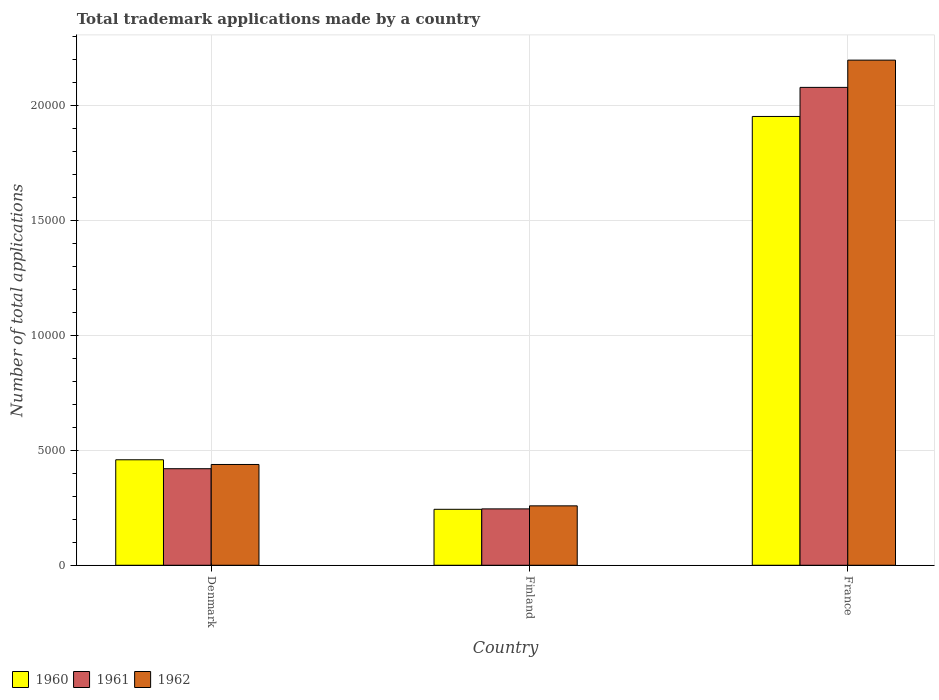How many groups of bars are there?
Offer a very short reply. 3. Are the number of bars per tick equal to the number of legend labels?
Offer a terse response. Yes. Are the number of bars on each tick of the X-axis equal?
Offer a terse response. Yes. How many bars are there on the 3rd tick from the left?
Your response must be concise. 3. What is the number of applications made by in 1961 in France?
Your answer should be very brief. 2.08e+04. Across all countries, what is the maximum number of applications made by in 1960?
Your answer should be very brief. 1.95e+04. Across all countries, what is the minimum number of applications made by in 1962?
Offer a very short reply. 2582. What is the total number of applications made by in 1960 in the graph?
Ensure brevity in your answer.  2.65e+04. What is the difference between the number of applications made by in 1961 in Denmark and that in France?
Provide a short and direct response. -1.66e+04. What is the difference between the number of applications made by in 1960 in Finland and the number of applications made by in 1962 in Denmark?
Ensure brevity in your answer.  -1948. What is the average number of applications made by in 1961 per country?
Give a very brief answer. 9138. What is the difference between the number of applications made by of/in 1960 and number of applications made by of/in 1961 in France?
Make the answer very short. -1264. In how many countries, is the number of applications made by in 1960 greater than 17000?
Provide a succinct answer. 1. What is the ratio of the number of applications made by in 1962 in Finland to that in France?
Your answer should be compact. 0.12. Is the number of applications made by in 1961 in Denmark less than that in France?
Keep it short and to the point. Yes. Is the difference between the number of applications made by in 1960 in Finland and France greater than the difference between the number of applications made by in 1961 in Finland and France?
Your answer should be compact. Yes. What is the difference between the highest and the second highest number of applications made by in 1961?
Your answer should be compact. 1.83e+04. What is the difference between the highest and the lowest number of applications made by in 1961?
Your response must be concise. 1.83e+04. In how many countries, is the number of applications made by in 1961 greater than the average number of applications made by in 1961 taken over all countries?
Keep it short and to the point. 1. Is the sum of the number of applications made by in 1962 in Denmark and Finland greater than the maximum number of applications made by in 1960 across all countries?
Your answer should be very brief. No. What does the 3rd bar from the left in Finland represents?
Keep it short and to the point. 1962. What does the 3rd bar from the right in Finland represents?
Offer a very short reply. 1960. Is it the case that in every country, the sum of the number of applications made by in 1962 and number of applications made by in 1961 is greater than the number of applications made by in 1960?
Offer a very short reply. Yes. Are all the bars in the graph horizontal?
Offer a very short reply. No. Does the graph contain grids?
Ensure brevity in your answer.  Yes. Where does the legend appear in the graph?
Keep it short and to the point. Bottom left. What is the title of the graph?
Your answer should be compact. Total trademark applications made by a country. What is the label or title of the X-axis?
Provide a succinct answer. Country. What is the label or title of the Y-axis?
Keep it short and to the point. Number of total applications. What is the Number of total applications in 1960 in Denmark?
Offer a terse response. 4584. What is the Number of total applications in 1961 in Denmark?
Your response must be concise. 4196. What is the Number of total applications of 1962 in Denmark?
Your response must be concise. 4380. What is the Number of total applications in 1960 in Finland?
Your answer should be very brief. 2432. What is the Number of total applications in 1961 in Finland?
Your response must be concise. 2450. What is the Number of total applications of 1962 in Finland?
Offer a terse response. 2582. What is the Number of total applications in 1960 in France?
Keep it short and to the point. 1.95e+04. What is the Number of total applications in 1961 in France?
Your response must be concise. 2.08e+04. What is the Number of total applications of 1962 in France?
Your answer should be very brief. 2.20e+04. Across all countries, what is the maximum Number of total applications in 1960?
Your answer should be very brief. 1.95e+04. Across all countries, what is the maximum Number of total applications of 1961?
Ensure brevity in your answer.  2.08e+04. Across all countries, what is the maximum Number of total applications of 1962?
Provide a short and direct response. 2.20e+04. Across all countries, what is the minimum Number of total applications in 1960?
Keep it short and to the point. 2432. Across all countries, what is the minimum Number of total applications in 1961?
Your answer should be very brief. 2450. Across all countries, what is the minimum Number of total applications in 1962?
Provide a succinct answer. 2582. What is the total Number of total applications of 1960 in the graph?
Offer a very short reply. 2.65e+04. What is the total Number of total applications of 1961 in the graph?
Offer a very short reply. 2.74e+04. What is the total Number of total applications of 1962 in the graph?
Your response must be concise. 2.89e+04. What is the difference between the Number of total applications of 1960 in Denmark and that in Finland?
Provide a succinct answer. 2152. What is the difference between the Number of total applications in 1961 in Denmark and that in Finland?
Keep it short and to the point. 1746. What is the difference between the Number of total applications in 1962 in Denmark and that in Finland?
Offer a very short reply. 1798. What is the difference between the Number of total applications of 1960 in Denmark and that in France?
Make the answer very short. -1.49e+04. What is the difference between the Number of total applications in 1961 in Denmark and that in France?
Your answer should be compact. -1.66e+04. What is the difference between the Number of total applications of 1962 in Denmark and that in France?
Provide a succinct answer. -1.76e+04. What is the difference between the Number of total applications in 1960 in Finland and that in France?
Make the answer very short. -1.71e+04. What is the difference between the Number of total applications in 1961 in Finland and that in France?
Keep it short and to the point. -1.83e+04. What is the difference between the Number of total applications in 1962 in Finland and that in France?
Offer a very short reply. -1.94e+04. What is the difference between the Number of total applications of 1960 in Denmark and the Number of total applications of 1961 in Finland?
Offer a very short reply. 2134. What is the difference between the Number of total applications in 1960 in Denmark and the Number of total applications in 1962 in Finland?
Make the answer very short. 2002. What is the difference between the Number of total applications of 1961 in Denmark and the Number of total applications of 1962 in Finland?
Provide a succinct answer. 1614. What is the difference between the Number of total applications in 1960 in Denmark and the Number of total applications in 1961 in France?
Provide a succinct answer. -1.62e+04. What is the difference between the Number of total applications of 1960 in Denmark and the Number of total applications of 1962 in France?
Provide a short and direct response. -1.74e+04. What is the difference between the Number of total applications in 1961 in Denmark and the Number of total applications in 1962 in France?
Ensure brevity in your answer.  -1.78e+04. What is the difference between the Number of total applications of 1960 in Finland and the Number of total applications of 1961 in France?
Give a very brief answer. -1.83e+04. What is the difference between the Number of total applications in 1960 in Finland and the Number of total applications in 1962 in France?
Make the answer very short. -1.95e+04. What is the difference between the Number of total applications in 1961 in Finland and the Number of total applications in 1962 in France?
Keep it short and to the point. -1.95e+04. What is the average Number of total applications of 1960 per country?
Provide a short and direct response. 8840. What is the average Number of total applications of 1961 per country?
Provide a succinct answer. 9138. What is the average Number of total applications in 1962 per country?
Ensure brevity in your answer.  9638. What is the difference between the Number of total applications of 1960 and Number of total applications of 1961 in Denmark?
Provide a short and direct response. 388. What is the difference between the Number of total applications of 1960 and Number of total applications of 1962 in Denmark?
Your response must be concise. 204. What is the difference between the Number of total applications of 1961 and Number of total applications of 1962 in Denmark?
Keep it short and to the point. -184. What is the difference between the Number of total applications in 1960 and Number of total applications in 1962 in Finland?
Keep it short and to the point. -150. What is the difference between the Number of total applications in 1961 and Number of total applications in 1962 in Finland?
Offer a terse response. -132. What is the difference between the Number of total applications of 1960 and Number of total applications of 1961 in France?
Keep it short and to the point. -1264. What is the difference between the Number of total applications in 1960 and Number of total applications in 1962 in France?
Provide a succinct answer. -2448. What is the difference between the Number of total applications of 1961 and Number of total applications of 1962 in France?
Your answer should be very brief. -1184. What is the ratio of the Number of total applications of 1960 in Denmark to that in Finland?
Offer a terse response. 1.88. What is the ratio of the Number of total applications in 1961 in Denmark to that in Finland?
Provide a short and direct response. 1.71. What is the ratio of the Number of total applications in 1962 in Denmark to that in Finland?
Offer a very short reply. 1.7. What is the ratio of the Number of total applications in 1960 in Denmark to that in France?
Offer a very short reply. 0.23. What is the ratio of the Number of total applications of 1961 in Denmark to that in France?
Give a very brief answer. 0.2. What is the ratio of the Number of total applications in 1962 in Denmark to that in France?
Your response must be concise. 0.2. What is the ratio of the Number of total applications of 1960 in Finland to that in France?
Ensure brevity in your answer.  0.12. What is the ratio of the Number of total applications of 1961 in Finland to that in France?
Provide a succinct answer. 0.12. What is the ratio of the Number of total applications of 1962 in Finland to that in France?
Make the answer very short. 0.12. What is the difference between the highest and the second highest Number of total applications in 1960?
Offer a very short reply. 1.49e+04. What is the difference between the highest and the second highest Number of total applications in 1961?
Provide a succinct answer. 1.66e+04. What is the difference between the highest and the second highest Number of total applications in 1962?
Ensure brevity in your answer.  1.76e+04. What is the difference between the highest and the lowest Number of total applications of 1960?
Your answer should be compact. 1.71e+04. What is the difference between the highest and the lowest Number of total applications of 1961?
Provide a short and direct response. 1.83e+04. What is the difference between the highest and the lowest Number of total applications of 1962?
Offer a very short reply. 1.94e+04. 